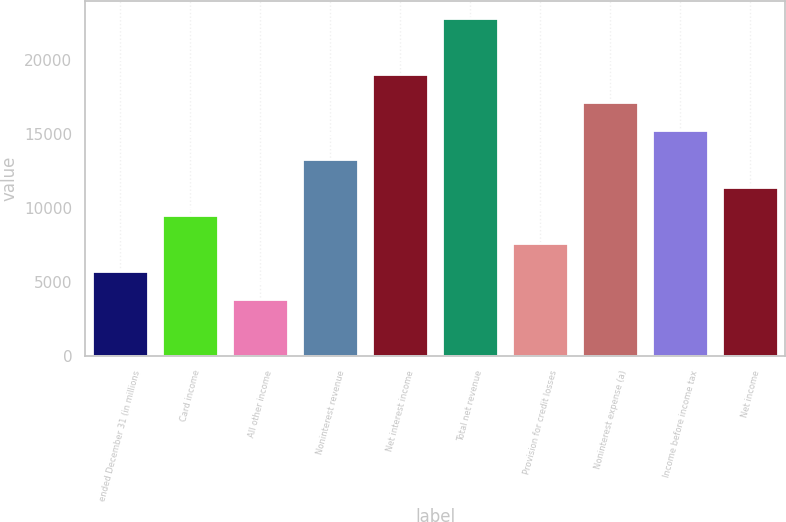Convert chart. <chart><loc_0><loc_0><loc_500><loc_500><bar_chart><fcel>ended December 31 (in millions<fcel>Card income<fcel>All other income<fcel>Noninterest revenue<fcel>Net interest income<fcel>Total net revenue<fcel>Provision for credit losses<fcel>Noninterest expense (a)<fcel>Income before income tax<fcel>Net income<nl><fcel>5722.1<fcel>9521.5<fcel>3822.4<fcel>13320.9<fcel>19020<fcel>22819.4<fcel>7621.8<fcel>17120.3<fcel>15220.6<fcel>11421.2<nl></chart> 